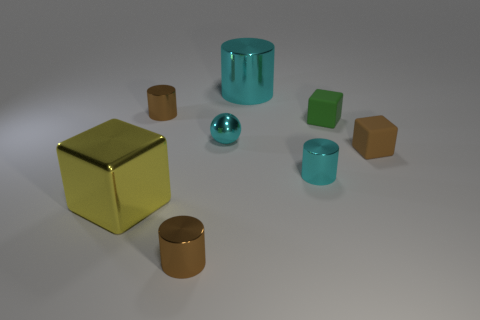Do the tiny ball and the small cylinder on the right side of the cyan sphere have the same color?
Give a very brief answer. Yes. Is there a big metallic thing of the same color as the sphere?
Offer a very short reply. Yes. What number of tiny things are either yellow spheres or yellow cubes?
Ensure brevity in your answer.  0. What material is the tiny thing that is the same color as the ball?
Keep it short and to the point. Metal. Are there fewer cyan spheres than brown metal things?
Ensure brevity in your answer.  Yes. Is the size of the cyan shiny object that is behind the green matte object the same as the block that is to the left of the large cylinder?
Ensure brevity in your answer.  Yes. How many blue objects are blocks or metallic spheres?
Keep it short and to the point. 0. There is another cylinder that is the same color as the big shiny cylinder; what size is it?
Your answer should be compact. Small. Are there more big gray things than green blocks?
Offer a very short reply. No. Do the large metallic cylinder and the metallic ball have the same color?
Keep it short and to the point. Yes. 